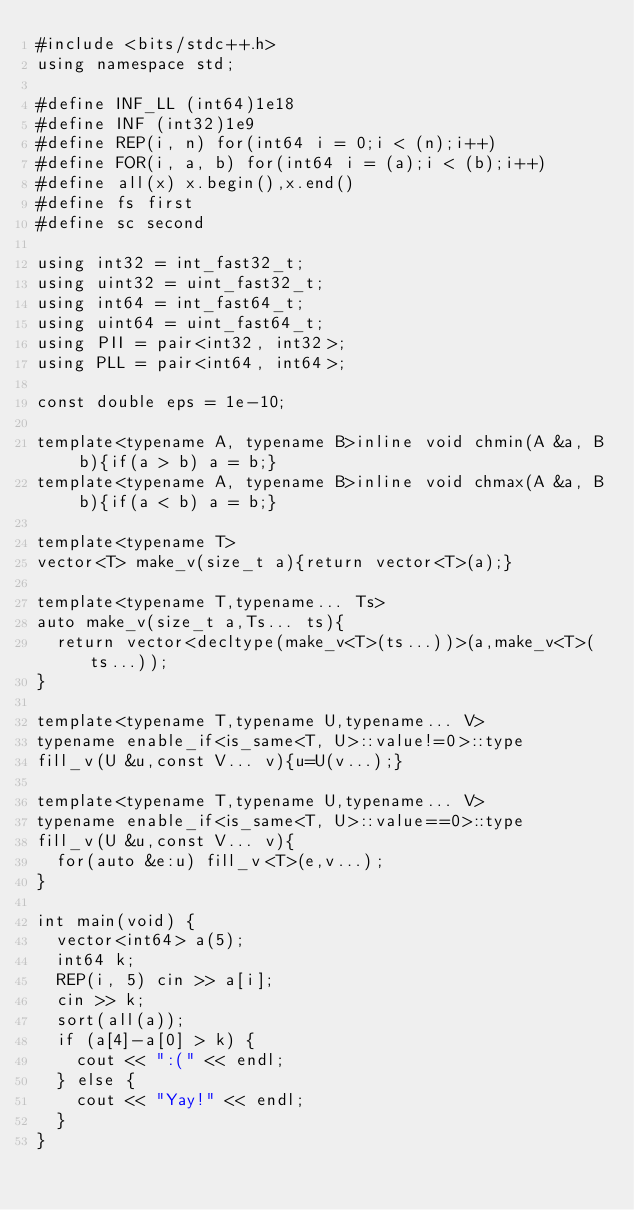<code> <loc_0><loc_0><loc_500><loc_500><_C++_>#include <bits/stdc++.h>
using namespace std;

#define INF_LL (int64)1e18
#define INF (int32)1e9
#define REP(i, n) for(int64 i = 0;i < (n);i++)
#define FOR(i, a, b) for(int64 i = (a);i < (b);i++)
#define all(x) x.begin(),x.end()
#define fs first
#define sc second

using int32 = int_fast32_t;
using uint32 = uint_fast32_t;
using int64 = int_fast64_t;
using uint64 = uint_fast64_t;
using PII = pair<int32, int32>;
using PLL = pair<int64, int64>;

const double eps = 1e-10;

template<typename A, typename B>inline void chmin(A &a, B b){if(a > b) a = b;}
template<typename A, typename B>inline void chmax(A &a, B b){if(a < b) a = b;}

template<typename T>
vector<T> make_v(size_t a){return vector<T>(a);}

template<typename T,typename... Ts>
auto make_v(size_t a,Ts... ts){
  return vector<decltype(make_v<T>(ts...))>(a,make_v<T>(ts...));
}

template<typename T,typename U,typename... V>
typename enable_if<is_same<T, U>::value!=0>::type
fill_v(U &u,const V... v){u=U(v...);}

template<typename T,typename U,typename... V>
typename enable_if<is_same<T, U>::value==0>::type
fill_v(U &u,const V... v){
  for(auto &e:u) fill_v<T>(e,v...);
}

int main(void) {
	vector<int64> a(5);
	int64 k;
	REP(i, 5) cin >> a[i];
	cin >> k;
	sort(all(a));
	if (a[4]-a[0] > k) {
		cout << ":(" << endl;
	} else {
		cout << "Yay!" << endl;
	}
}
</code> 